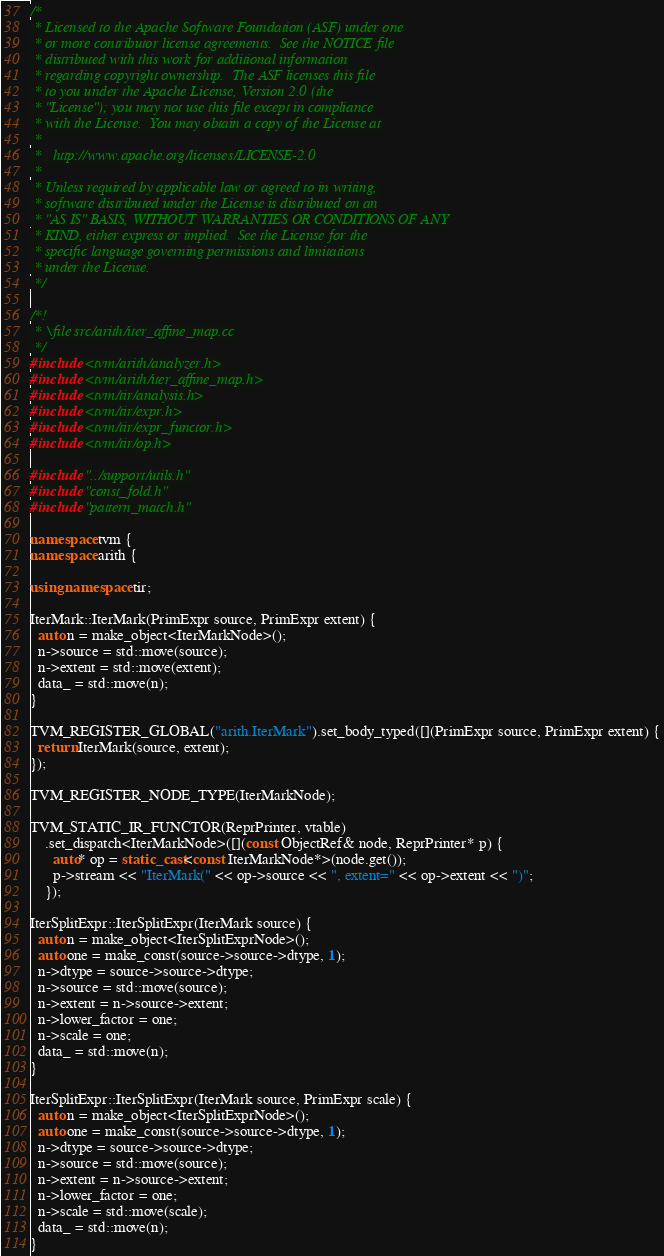<code> <loc_0><loc_0><loc_500><loc_500><_C++_>/*
 * Licensed to the Apache Software Foundation (ASF) under one
 * or more contributor license agreements.  See the NOTICE file
 * distributed with this work for additional information
 * regarding copyright ownership.  The ASF licenses this file
 * to you under the Apache License, Version 2.0 (the
 * "License"); you may not use this file except in compliance
 * with the License.  You may obtain a copy of the License at
 *
 *   http://www.apache.org/licenses/LICENSE-2.0
 *
 * Unless required by applicable law or agreed to in writing,
 * software distributed under the License is distributed on an
 * "AS IS" BASIS, WITHOUT WARRANTIES OR CONDITIONS OF ANY
 * KIND, either express or implied.  See the License for the
 * specific language governing permissions and limitations
 * under the License.
 */

/*!
 * \file src/arith/iter_affine_map.cc
 */
#include <tvm/arith/analyzer.h>
#include <tvm/arith/iter_affine_map.h>
#include <tvm/tir/analysis.h>
#include <tvm/tir/expr.h>
#include <tvm/tir/expr_functor.h>
#include <tvm/tir/op.h>

#include "../support/utils.h"
#include "const_fold.h"
#include "pattern_match.h"

namespace tvm {
namespace arith {

using namespace tir;

IterMark::IterMark(PrimExpr source, PrimExpr extent) {
  auto n = make_object<IterMarkNode>();
  n->source = std::move(source);
  n->extent = std::move(extent);
  data_ = std::move(n);
}

TVM_REGISTER_GLOBAL("arith.IterMark").set_body_typed([](PrimExpr source, PrimExpr extent) {
  return IterMark(source, extent);
});

TVM_REGISTER_NODE_TYPE(IterMarkNode);

TVM_STATIC_IR_FUNCTOR(ReprPrinter, vtable)
    .set_dispatch<IterMarkNode>([](const ObjectRef& node, ReprPrinter* p) {
      auto* op = static_cast<const IterMarkNode*>(node.get());
      p->stream << "IterMark(" << op->source << ", extent=" << op->extent << ")";
    });

IterSplitExpr::IterSplitExpr(IterMark source) {
  auto n = make_object<IterSplitExprNode>();
  auto one = make_const(source->source->dtype, 1);
  n->dtype = source->source->dtype;
  n->source = std::move(source);
  n->extent = n->source->extent;
  n->lower_factor = one;
  n->scale = one;
  data_ = std::move(n);
}

IterSplitExpr::IterSplitExpr(IterMark source, PrimExpr scale) {
  auto n = make_object<IterSplitExprNode>();
  auto one = make_const(source->source->dtype, 1);
  n->dtype = source->source->dtype;
  n->source = std::move(source);
  n->extent = n->source->extent;
  n->lower_factor = one;
  n->scale = std::move(scale);
  data_ = std::move(n);
}
</code> 